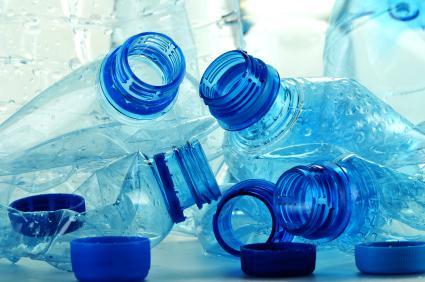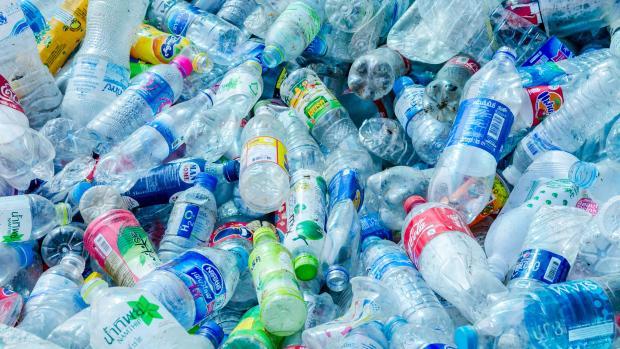The first image is the image on the left, the second image is the image on the right. Evaluate the accuracy of this statement regarding the images: "There is a variety of bottle in one of the images.". Is it true? Answer yes or no. Yes. 